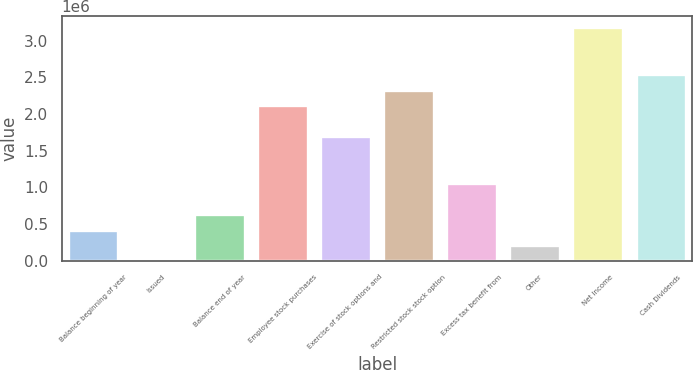<chart> <loc_0><loc_0><loc_500><loc_500><bar_chart><fcel>Balance beginning of year<fcel>Issued<fcel>Balance end of year<fcel>Employee stock purchases<fcel>Exercise of stock options and<fcel>Restricted stock stock option<fcel>Excess tax benefit from<fcel>Other<fcel>Net Income<fcel>Cash Dividends<nl><fcel>424266<fcel>26<fcel>636386<fcel>2.12123e+06<fcel>1.69699e+06<fcel>2.33335e+06<fcel>1.06063e+06<fcel>212146<fcel>3.18183e+06<fcel>2.54547e+06<nl></chart> 